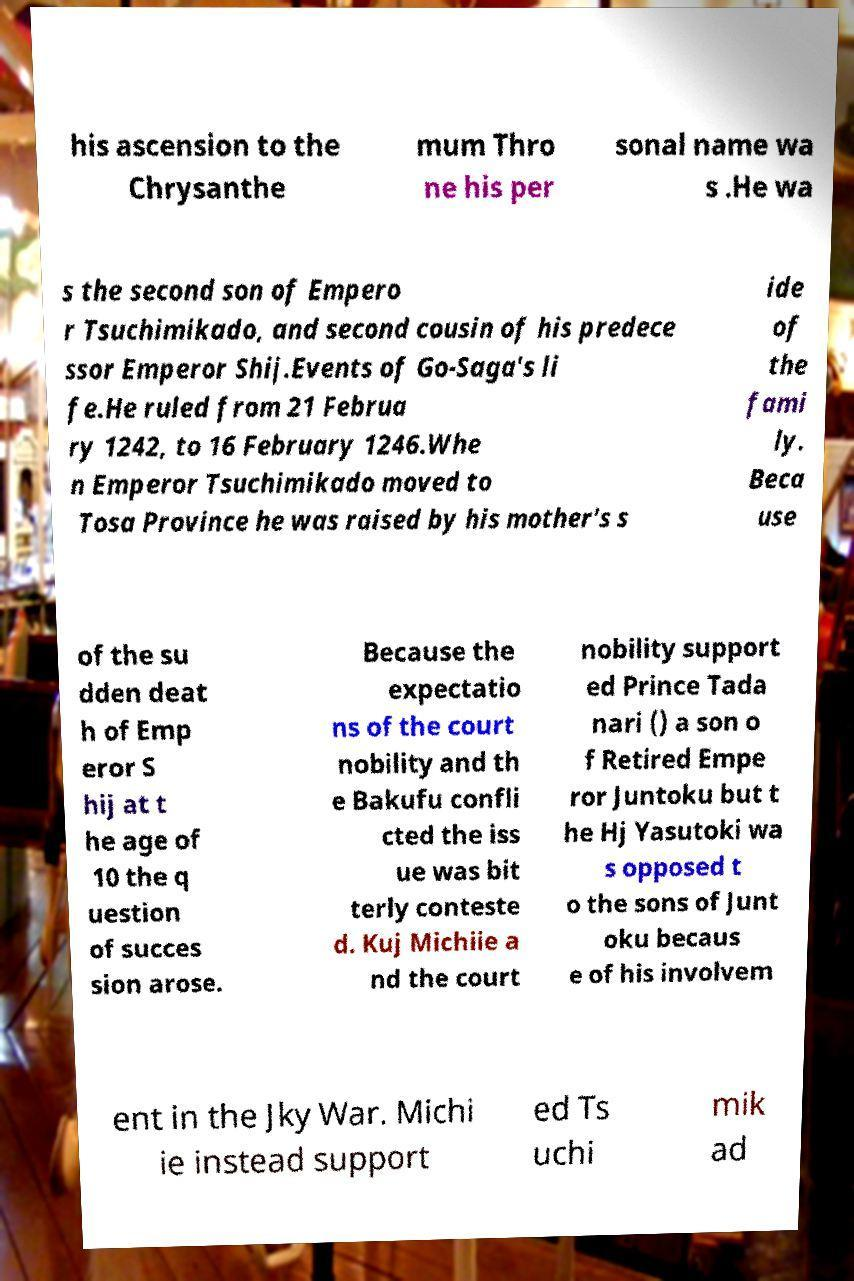Could you assist in decoding the text presented in this image and type it out clearly? his ascension to the Chrysanthe mum Thro ne his per sonal name wa s .He wa s the second son of Empero r Tsuchimikado, and second cousin of his predece ssor Emperor Shij.Events of Go-Saga's li fe.He ruled from 21 Februa ry 1242, to 16 February 1246.Whe n Emperor Tsuchimikado moved to Tosa Province he was raised by his mother's s ide of the fami ly. Beca use of the su dden deat h of Emp eror S hij at t he age of 10 the q uestion of succes sion arose. Because the expectatio ns of the court nobility and th e Bakufu confli cted the iss ue was bit terly conteste d. Kuj Michiie a nd the court nobility support ed Prince Tada nari () a son o f Retired Empe ror Juntoku but t he Hj Yasutoki wa s opposed t o the sons of Junt oku becaus e of his involvem ent in the Jky War. Michi ie instead support ed Ts uchi mik ad 